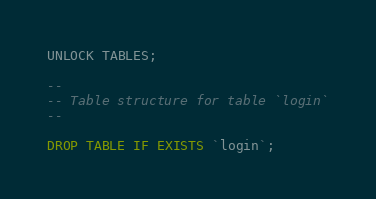<code> <loc_0><loc_0><loc_500><loc_500><_SQL_>UNLOCK TABLES;

--
-- Table structure for table `login`
--

DROP TABLE IF EXISTS `login`;</code> 